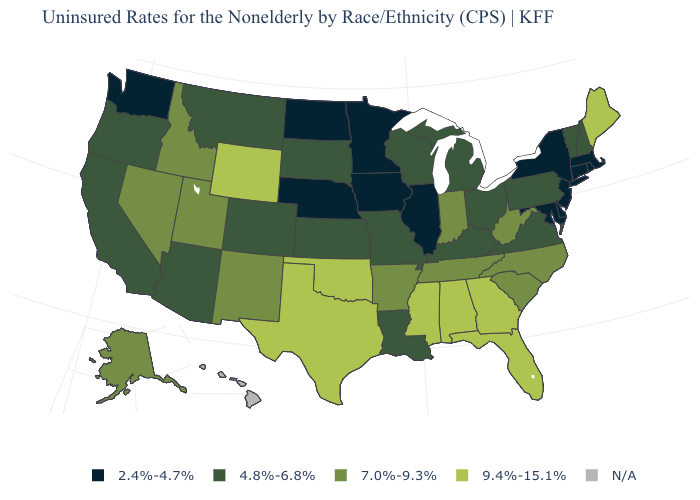What is the highest value in the USA?
Answer briefly. 9.4%-15.1%. Name the states that have a value in the range 9.4%-15.1%?
Short answer required. Alabama, Florida, Georgia, Maine, Mississippi, Oklahoma, Texas, Wyoming. What is the lowest value in the USA?
Concise answer only. 2.4%-4.7%. Name the states that have a value in the range 4.8%-6.8%?
Short answer required. Arizona, California, Colorado, Kansas, Kentucky, Louisiana, Michigan, Missouri, Montana, New Hampshire, Ohio, Oregon, Pennsylvania, South Dakota, Vermont, Virginia, Wisconsin. Name the states that have a value in the range 7.0%-9.3%?
Quick response, please. Alaska, Arkansas, Idaho, Indiana, Nevada, New Mexico, North Carolina, South Carolina, Tennessee, Utah, West Virginia. What is the lowest value in the West?
Concise answer only. 2.4%-4.7%. Does the map have missing data?
Short answer required. Yes. What is the lowest value in the USA?
Short answer required. 2.4%-4.7%. Name the states that have a value in the range 7.0%-9.3%?
Short answer required. Alaska, Arkansas, Idaho, Indiana, Nevada, New Mexico, North Carolina, South Carolina, Tennessee, Utah, West Virginia. Does Minnesota have the lowest value in the MidWest?
Concise answer only. Yes. Name the states that have a value in the range N/A?
Short answer required. Hawaii. What is the value of Indiana?
Write a very short answer. 7.0%-9.3%. What is the lowest value in states that border Florida?
Answer briefly. 9.4%-15.1%. Does the map have missing data?
Answer briefly. Yes. 